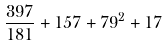<formula> <loc_0><loc_0><loc_500><loc_500>\frac { 3 9 7 } { 1 8 1 } + 1 5 7 + 7 9 ^ { 2 } + 1 7</formula> 